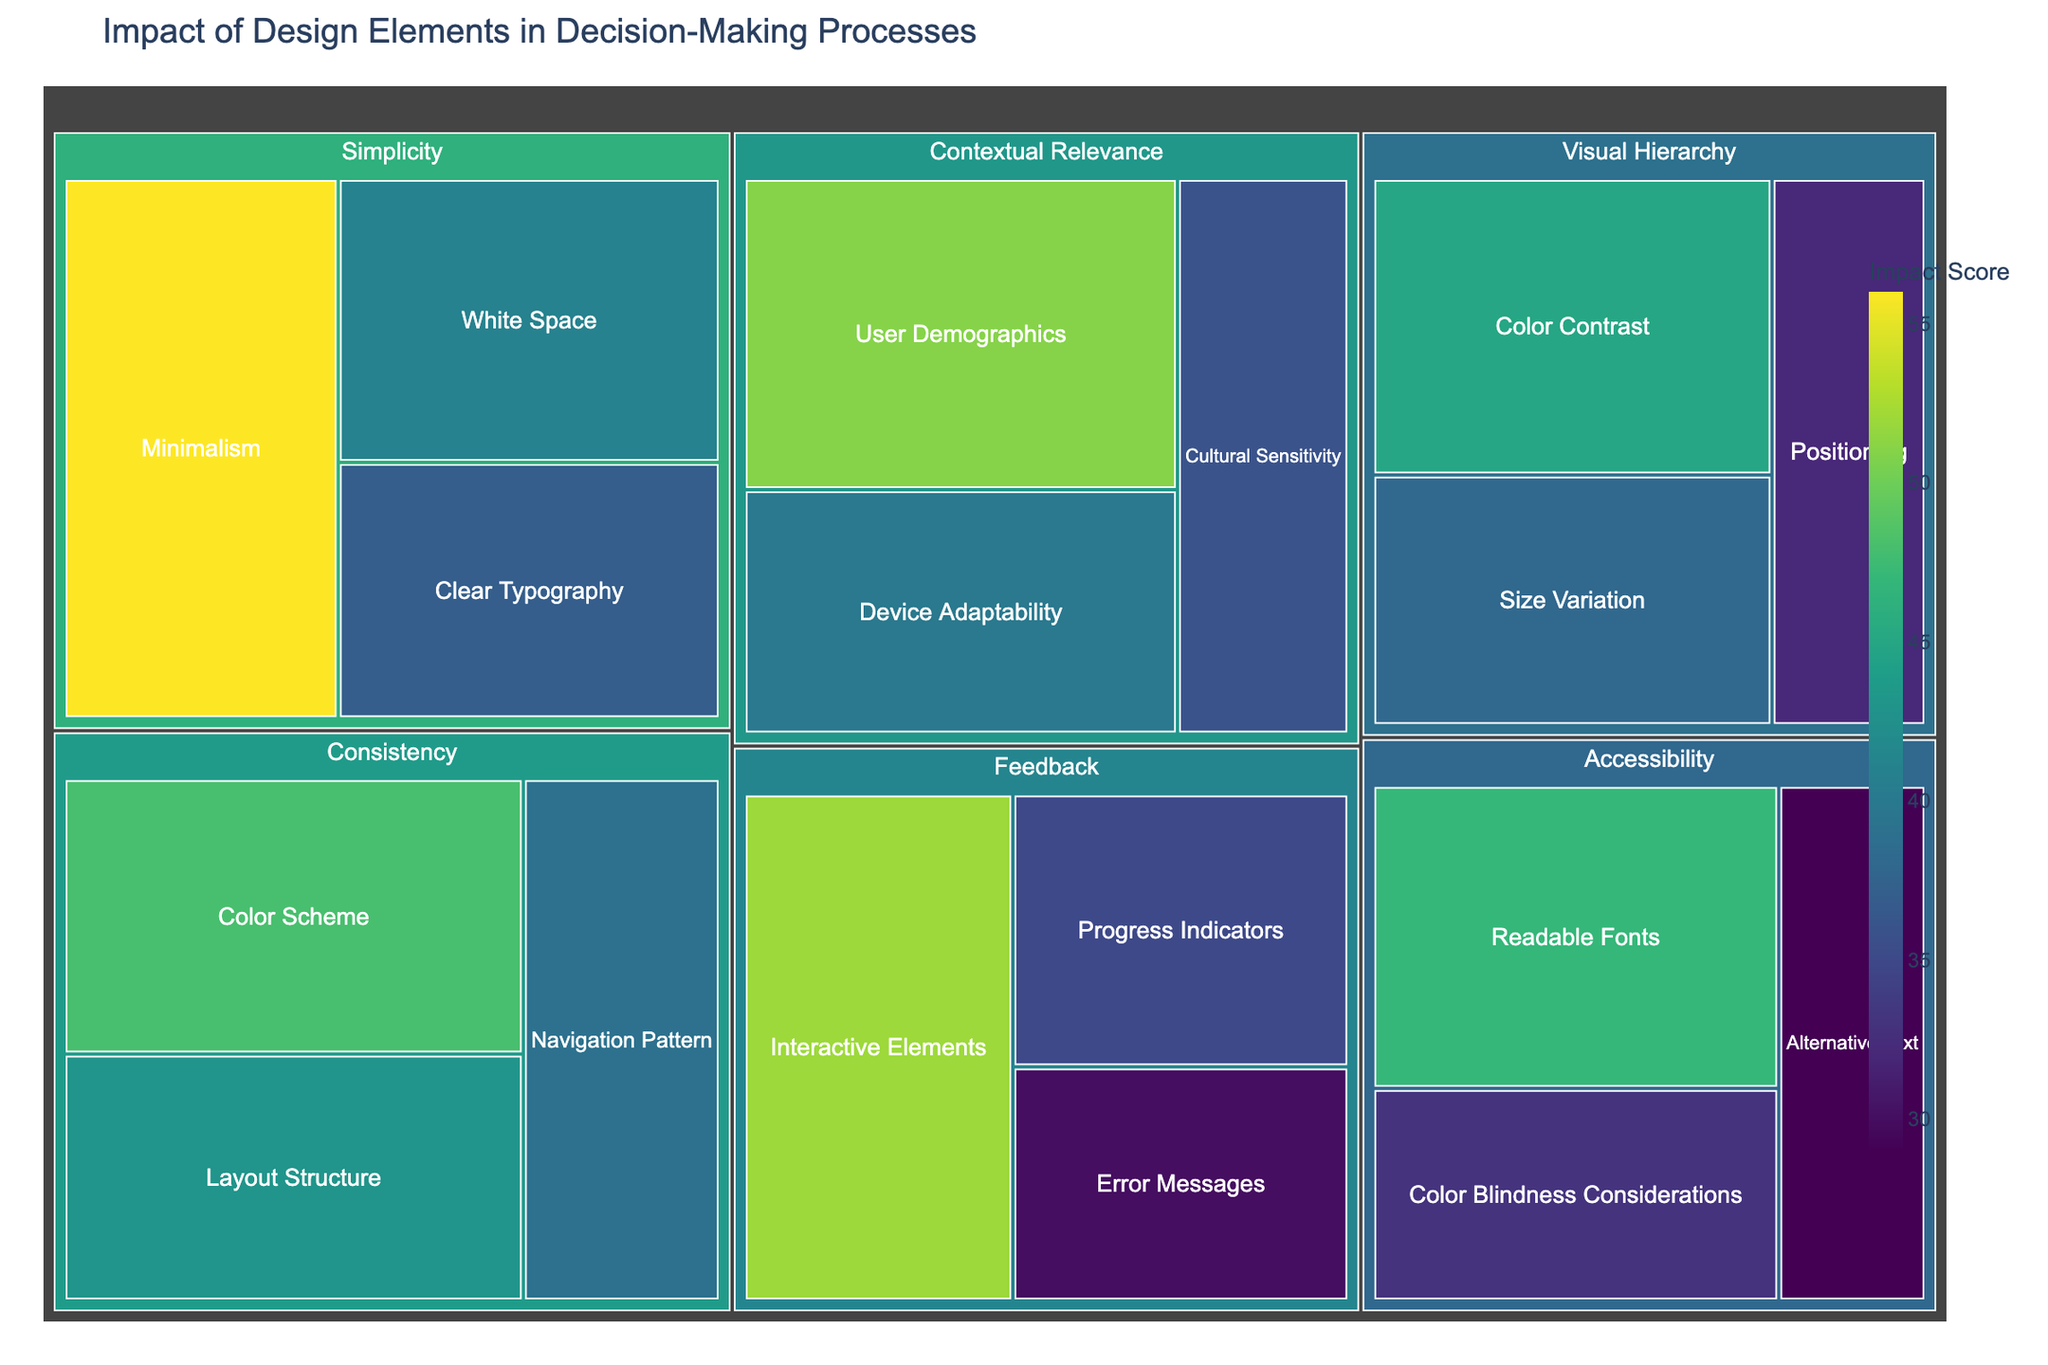What is the title of the treemap? The title of the treemap is typically displayed at the top of the figure. This treemap's title is directly stated in the provided code.
Answer: Impact of Design Elements in Decision-Making Processes Which subcategory under Visual Hierarchy has the highest impact? Under the category Visual Hierarchy, the subcategories are Color Contrast, Size Variation, and Positioning. By examining their impact values, Color Contrast has the highest impact value of 45.
Answer: Color Contrast What is the impact score for Minimalism under Simplicity? Minimalism falls under the Simplicity category. By looking at the provided values, Minimalism has an impact score of 56.
Answer: 56 Which category has the highest overall impact score? To determine the category with the highest overall impact score, sum the values of the subcategories for each category and compare the totals. For instance, Simplicity has subcategory values of 56, 41, and 37 which sum to 134. Similarly calculate for other categories. Simplicity has the highest total score.
Answer: Simplicity What is the sum of the impact scores for Color Scheme and Navigation Pattern? Color Scheme and Navigation Pattern belong to the Consistency category with values of 48 and 39 respectively. Adding these values gives us 48 + 39 = 87.
Answer: 87 Which subcategory under Accessibility has the lowest impact score? The subcategories under Accessibility are Readable Fonts, Color Blindness Considerations, and Alternative Text. By checking their values, Alternative Text has the lowest impact score of 29.
Answer: Alternative Text How does the impact of Interactive Elements compare to that of Progress Indicators? Interactive Elements and Progress Indicators are both under the Feedback category. Their impact scores are 52 and 35 respectively. By comparing them, Interactive Elements has a higher impact score.
Answer: Interactive Elements has a higher impact What is the average impact score of all subcategories under Contextual Relevance? The subcategories under Contextual Relevance are User Demographics (51), Cultural Sensitivity (36), and Device Adaptability (40). The sum of these values is 51 + 36 + 40 = 127. Dividing by the number of subcategories (3), the average is 127 / 3 = 42.33.
Answer: 42.33 Which category has the widest range of impact scores? To find the category with the widest range of impact scores, calculate the difference between the highest and lowest values for each category. For example: 
- Visual Hierarchy: 45 - 32 = 13
- Simplicity: 56 - 37 = 19
- Consistency: 48 - 39 = 9
- Feedback: 52 - 30 = 22
- Accessibility: 47 - 29 = 18
- Contextual Relevance: 51 - 36 = 15
The Feedback category has the widest range of impact scores with a range of 22.
Answer: Feedback 